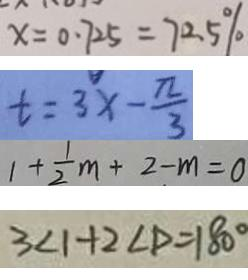<formula> <loc_0><loc_0><loc_500><loc_500>x = 0 . 7 2 5 = 7 2 . 5 \% 
 t = 3 x - \frac { \pi } { 3 } 
 1 + \frac { 1 } { 2 } m + 2 - m = 0 
 3 < 1 + 2 \angle D = 1 8 0 ^ { \circ }</formula> 